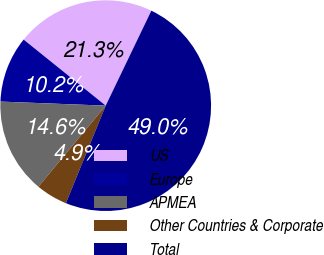Convert chart to OTSL. <chart><loc_0><loc_0><loc_500><loc_500><pie_chart><fcel>US<fcel>Europe<fcel>APMEA<fcel>Other Countries & Corporate<fcel>Total<nl><fcel>21.35%<fcel>10.17%<fcel>14.59%<fcel>4.86%<fcel>49.04%<nl></chart> 